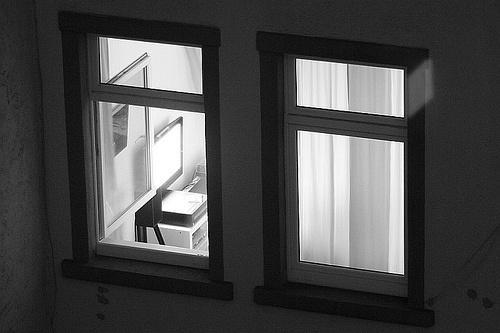Describe the objects in this image and their specific colors. I can see a tv in darkgray, lightgray, gray, black, and white tones in this image. 